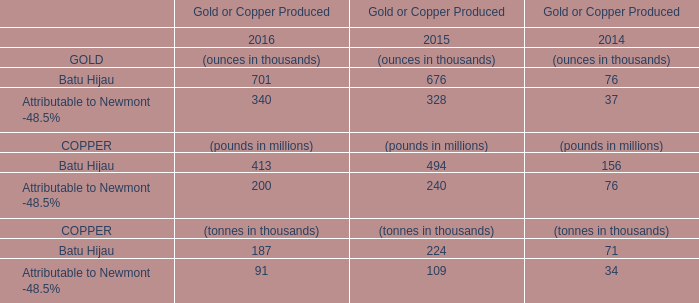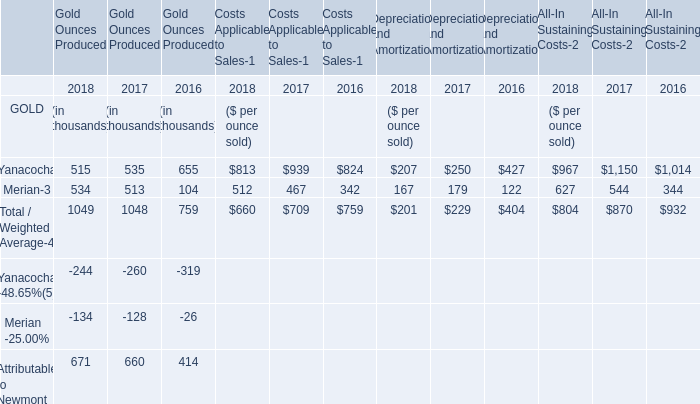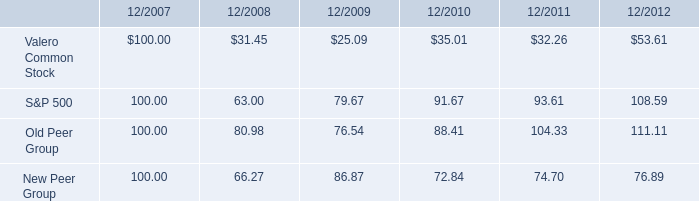what was the mathematical range for all four groups in 12/2010 , assuming investments of $ 100 initially in 2008? 
Computations: (91.67 - 35.01)
Answer: 56.66. 